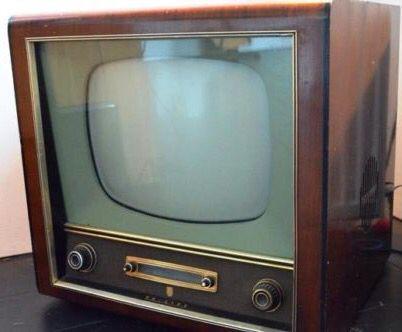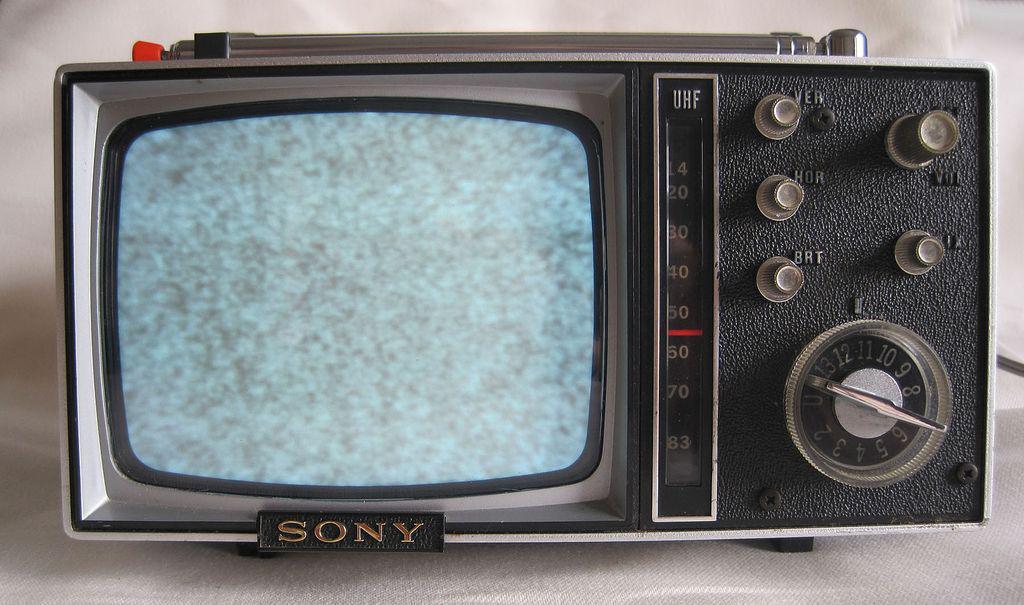The first image is the image on the left, the second image is the image on the right. Considering the images on both sides, is "the controls are right of the screen in the image on the right" valid? Answer yes or no. Yes. 